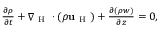Convert formula to latex. <formula><loc_0><loc_0><loc_500><loc_500>\begin{array} { r } { \frac { \partial \rho } { \partial t } + \nabla _ { H } \cdot ( \rho u _ { H } ) + \frac { \partial ( \rho w ) } { \partial z } = 0 , } \end{array}</formula> 